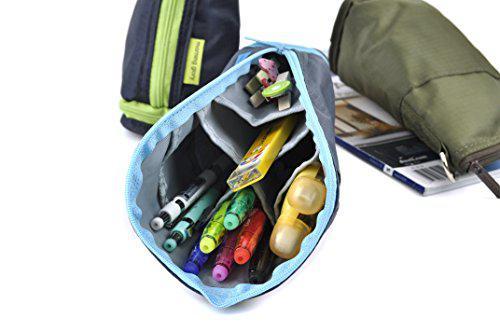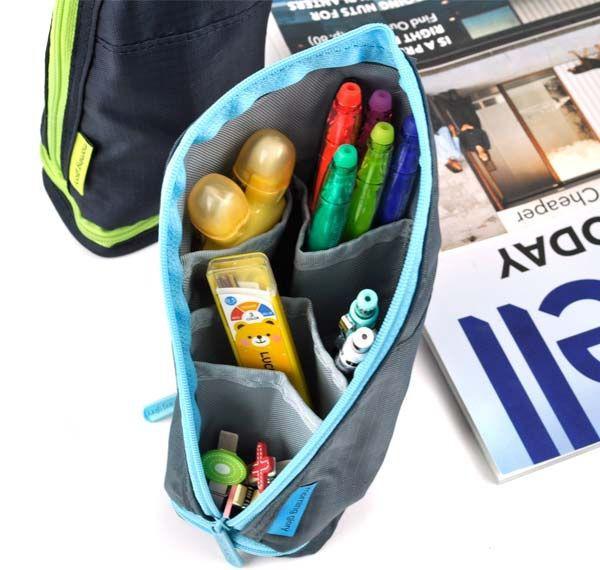The first image is the image on the left, the second image is the image on the right. For the images shown, is this caption "There are two pencil holders in the pair of images." true? Answer yes or no. No. The first image is the image on the left, the second image is the image on the right. Evaluate the accuracy of this statement regarding the images: "An image shows an upright pencil pouch with a patterned exterior, filled with only upright colored-lead pencils.". Is it true? Answer yes or no. No. 